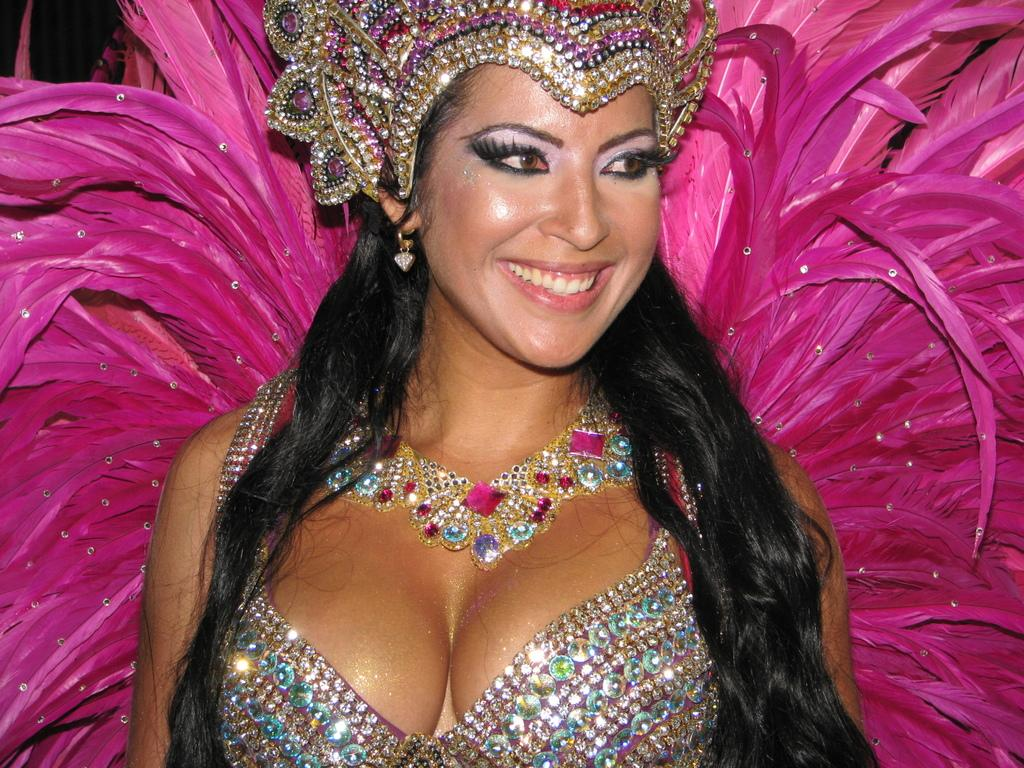Who is the main subject in the image? There is a woman in the image. What is the woman wearing? The woman is wearing a costume. What is the woman's facial expression? The woman is smiling. In which direction is the woman looking? The woman is looking towards the right side. What type of straw is the woman holding in the image? There is no straw present in the image. What is the woman's occupation, as indicated by her costume? The woman's costume does not indicate her occupation, and there is no mention of a minister in the image. 